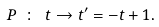<formula> <loc_0><loc_0><loc_500><loc_500>P \ \colon \ t \rightarrow t ^ { \prime } = - t + 1 .</formula> 